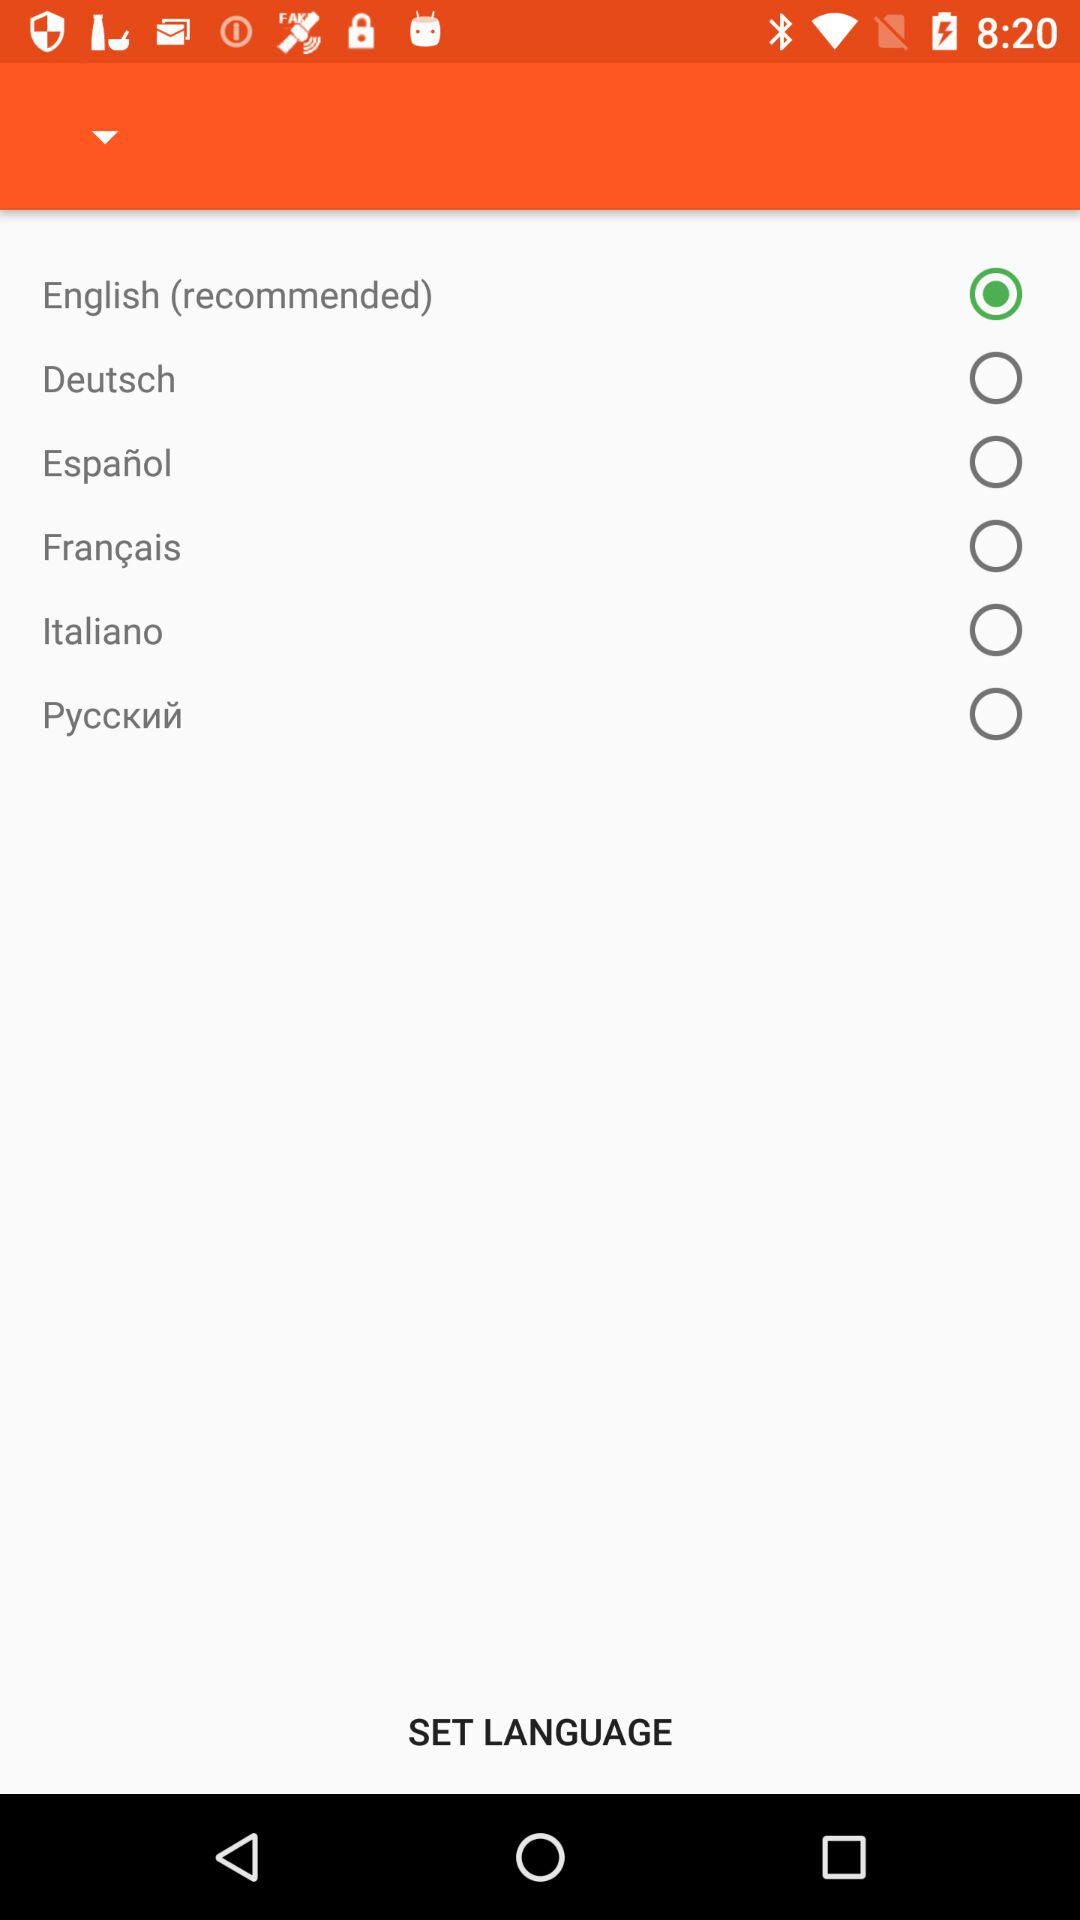Which language is selected? The selected language is English (recommended). 